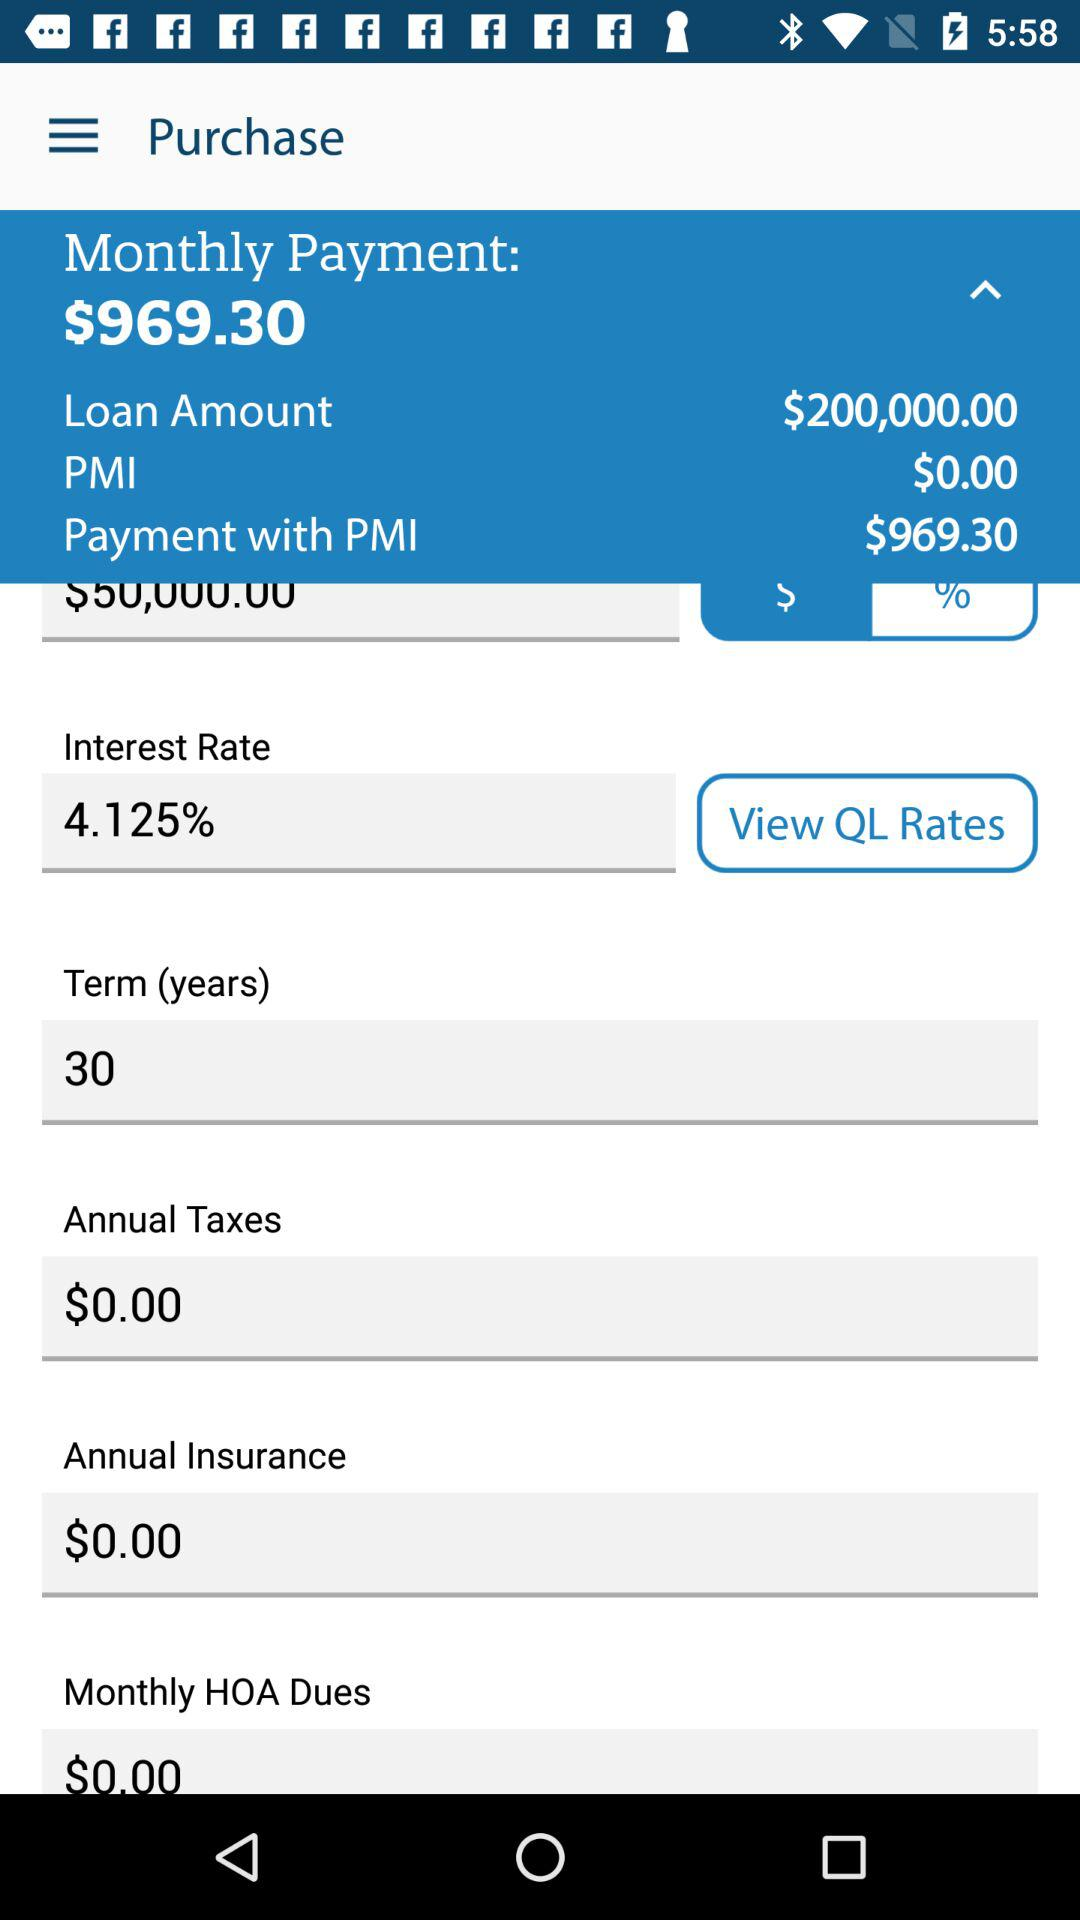How much is the loan amount? The loan amount is $200,000. 